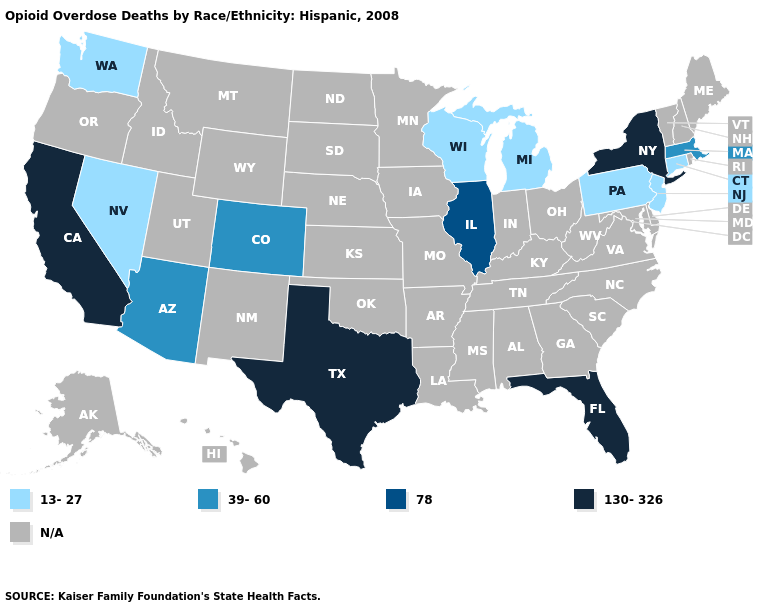What is the lowest value in the Northeast?
Write a very short answer. 13-27. What is the lowest value in the South?
Concise answer only. 130-326. Which states have the highest value in the USA?
Short answer required. California, Florida, New York, Texas. Which states have the highest value in the USA?
Write a very short answer. California, Florida, New York, Texas. Name the states that have a value in the range 130-326?
Short answer required. California, Florida, New York, Texas. What is the value of Wyoming?
Quick response, please. N/A. How many symbols are there in the legend?
Quick response, please. 5. What is the value of Iowa?
Answer briefly. N/A. Does the first symbol in the legend represent the smallest category?
Quick response, please. Yes. What is the value of North Dakota?
Write a very short answer. N/A. Name the states that have a value in the range 130-326?
Give a very brief answer. California, Florida, New York, Texas. What is the value of Maryland?
Give a very brief answer. N/A. 